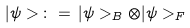<formula> <loc_0><loc_0><loc_500><loc_500>| \psi > \, \colon = \, | \psi > _ { B } \otimes | \psi > _ { F }</formula> 